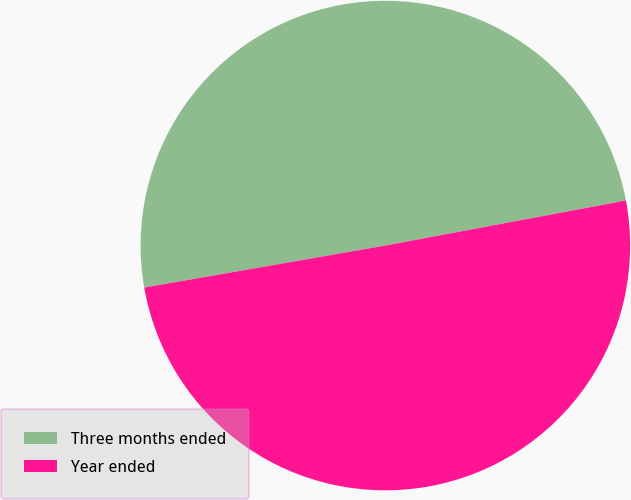<chart> <loc_0><loc_0><loc_500><loc_500><pie_chart><fcel>Three months ended<fcel>Year ended<nl><fcel>49.8%<fcel>50.2%<nl></chart> 